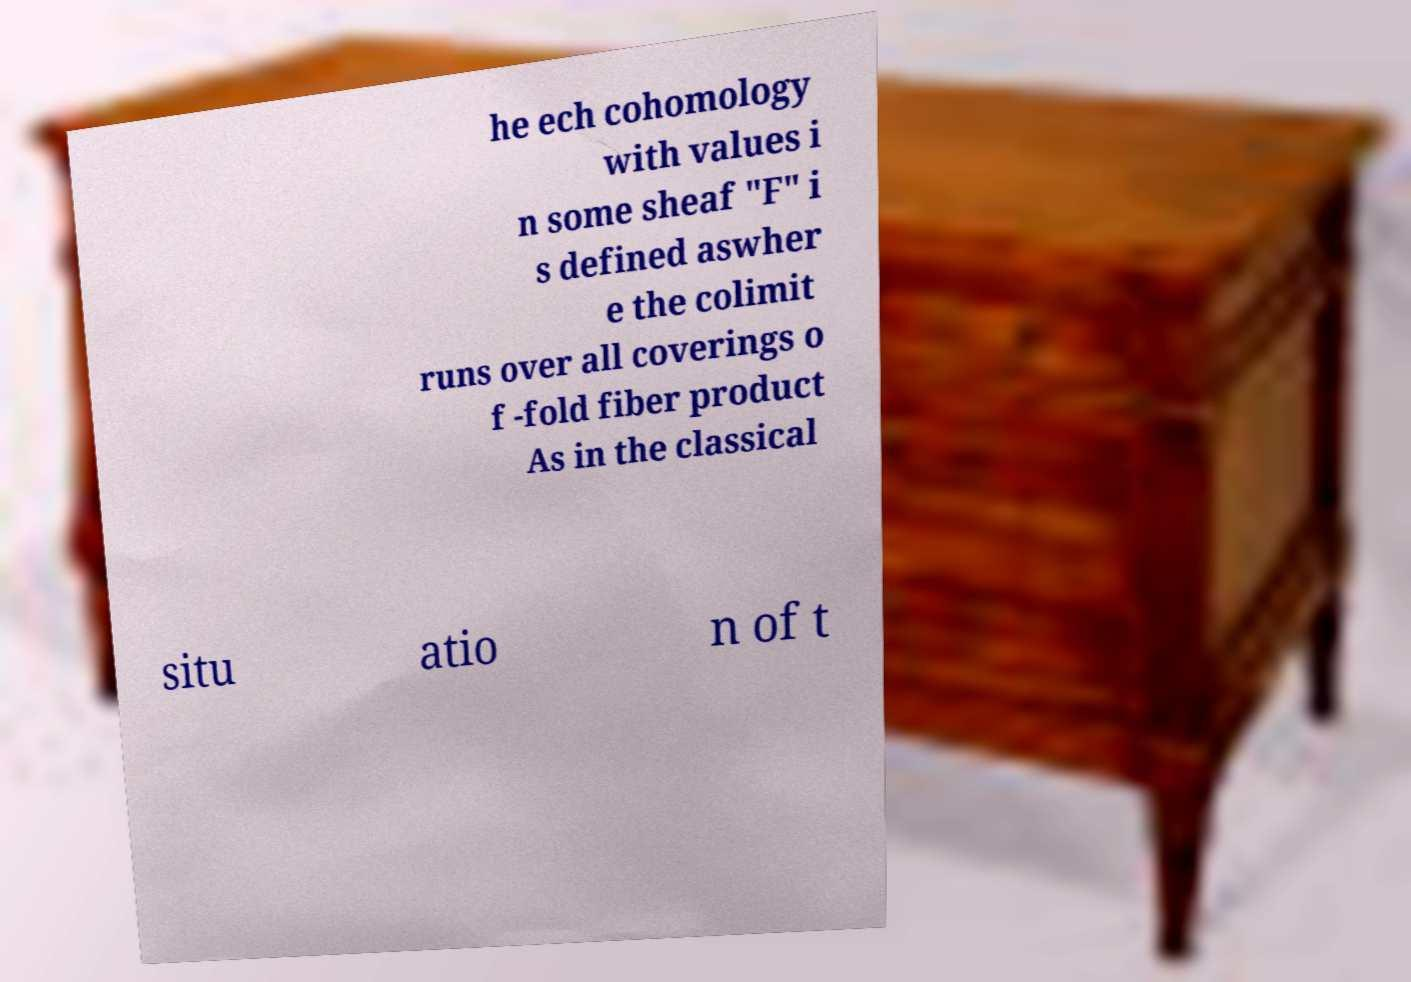Could you extract and type out the text from this image? he ech cohomology with values i n some sheaf "F" i s defined aswher e the colimit runs over all coverings o f -fold fiber product As in the classical situ atio n of t 